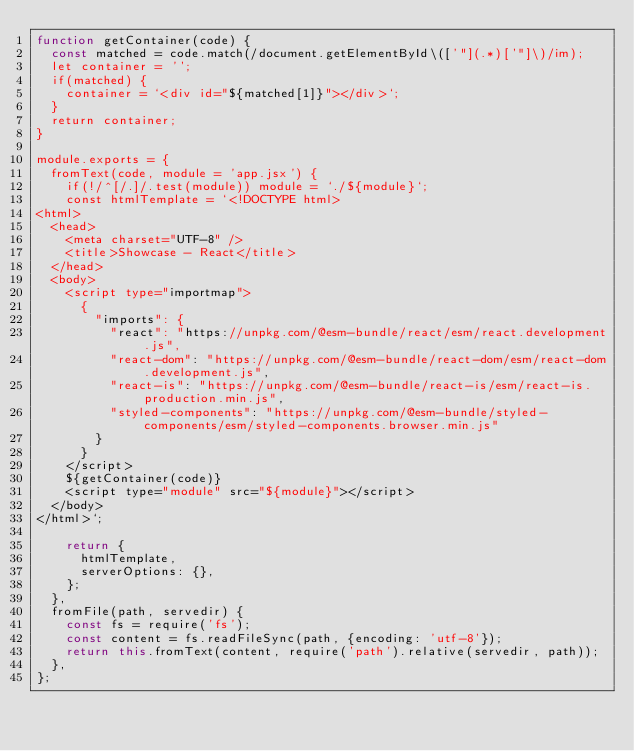<code> <loc_0><loc_0><loc_500><loc_500><_JavaScript_>function getContainer(code) {
  const matched = code.match(/document.getElementById\(['"](.*)['"]\)/im);
  let container = '';
  if(matched) {
    container = `<div id="${matched[1]}"></div>`;
  }
  return container;
}

module.exports = {
  fromText(code, module = 'app.jsx') {
    if(!/^[/.]/.test(module)) module = `./${module}`;
    const htmlTemplate = `<!DOCTYPE html>
<html>
  <head>
    <meta charset="UTF-8" />
    <title>Showcase - React</title>
  </head>
  <body>
    <script type="importmap">
      {
        "imports": {
          "react": "https://unpkg.com/@esm-bundle/react/esm/react.development.js",
          "react-dom": "https://unpkg.com/@esm-bundle/react-dom/esm/react-dom.development.js",
          "react-is": "https://unpkg.com/@esm-bundle/react-is/esm/react-is.production.min.js",
          "styled-components": "https://unpkg.com/@esm-bundle/styled-components/esm/styled-components.browser.min.js"
        }
      }
    </script>
    ${getContainer(code)}
    <script type="module" src="${module}"></script>
  </body>
</html>`;

    return {
      htmlTemplate,
      serverOptions: {},
    };
  },
  fromFile(path, servedir) {
    const fs = require('fs');
    const content = fs.readFileSync(path, {encoding: 'utf-8'});
    return this.fromText(content, require('path').relative(servedir, path));
  },
};</code> 